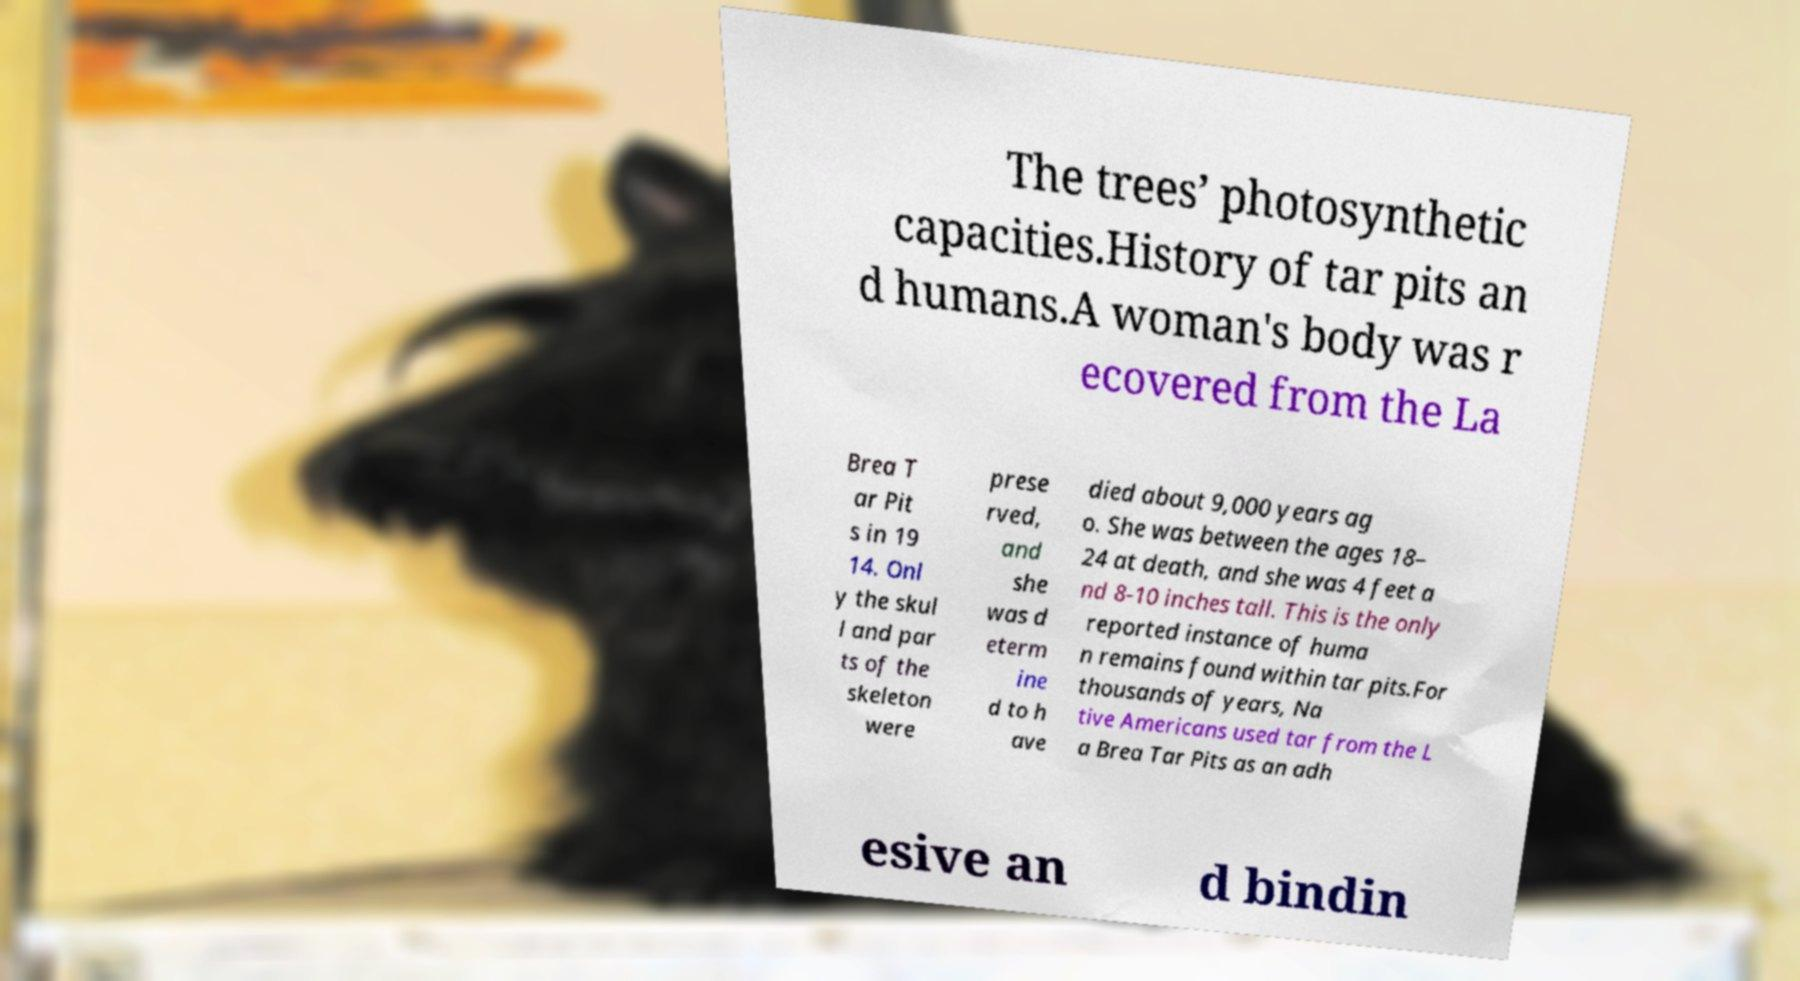What messages or text are displayed in this image? I need them in a readable, typed format. The trees’ photosynthetic capacities.History of tar pits an d humans.A woman's body was r ecovered from the La Brea T ar Pit s in 19 14. Onl y the skul l and par ts of the skeleton were prese rved, and she was d eterm ine d to h ave died about 9,000 years ag o. She was between the ages 18– 24 at death, and she was 4 feet a nd 8-10 inches tall. This is the only reported instance of huma n remains found within tar pits.For thousands of years, Na tive Americans used tar from the L a Brea Tar Pits as an adh esive an d bindin 